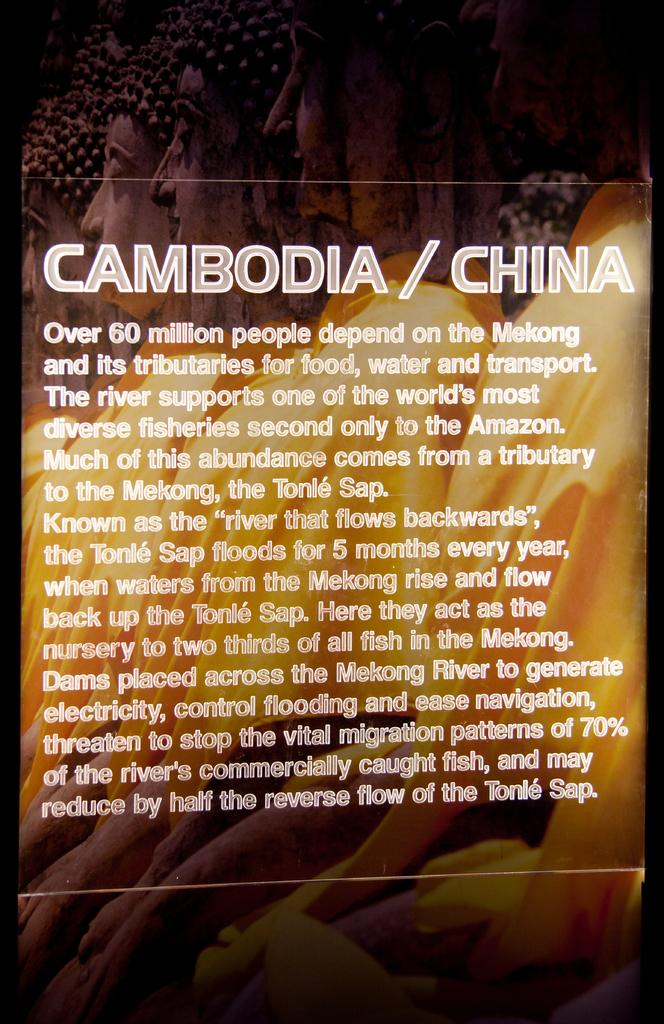<image>
Give a short and clear explanation of the subsequent image. a sign reading Cambodia China and giving info about damming the Mekong River 